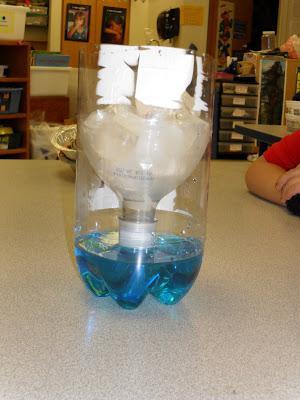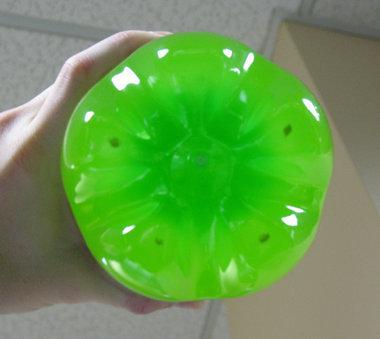The first image is the image on the left, the second image is the image on the right. Analyze the images presented: Is the assertion "The top of the bottle is sitting next to the bottom in one of the images." valid? Answer yes or no. No. The first image is the image on the left, the second image is the image on the right. Evaluate the accuracy of this statement regarding the images: "In at least one image there is a green soda bottle cut in to two pieces.". Is it true? Answer yes or no. No. 